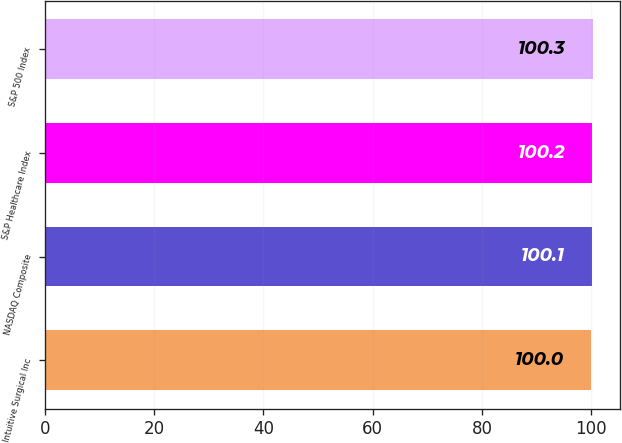<chart> <loc_0><loc_0><loc_500><loc_500><bar_chart><fcel>Intuitive Surgical Inc<fcel>NASDAQ Composite<fcel>S&P Healthcare Index<fcel>S&P 500 Index<nl><fcel>100<fcel>100.1<fcel>100.2<fcel>100.3<nl></chart> 